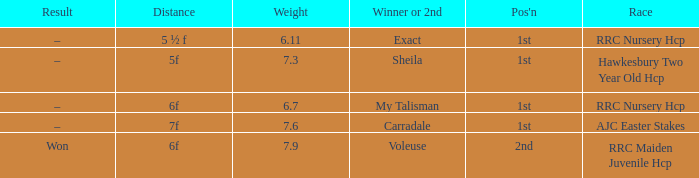What is the weight number when the distance was 5 ½ f? 1.0. 